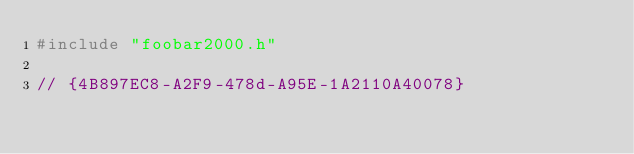<code> <loc_0><loc_0><loc_500><loc_500><_C++_>#include "foobar2000.h"

// {4B897EC8-A2F9-478d-A95E-1A2110A40078}</code> 